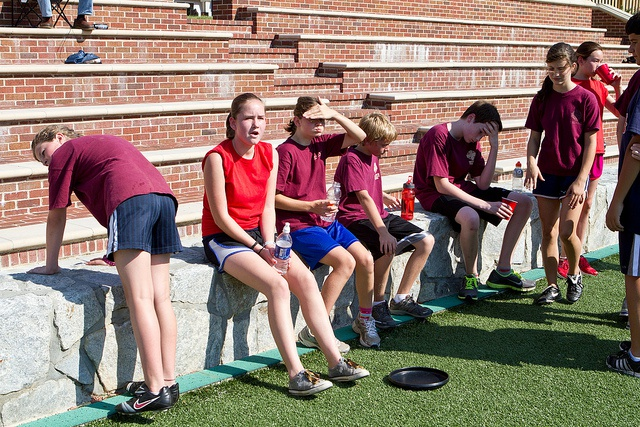Describe the objects in this image and their specific colors. I can see people in black, maroon, lightgray, and gray tones, people in black, lightgray, brown, and lightpink tones, people in black, maroon, gray, and lightgray tones, people in black, maroon, gray, and brown tones, and frisbee in black, gray, and darkgreen tones in this image. 